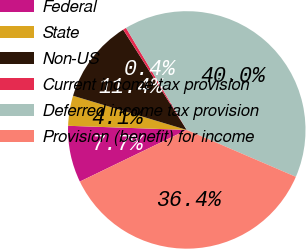Convert chart. <chart><loc_0><loc_0><loc_500><loc_500><pie_chart><fcel>Federal<fcel>State<fcel>Non-US<fcel>Current income tax provision<fcel>Deferred income tax provision<fcel>Provision (benefit) for income<nl><fcel>7.72%<fcel>4.09%<fcel>11.36%<fcel>0.45%<fcel>40.01%<fcel>36.37%<nl></chart> 